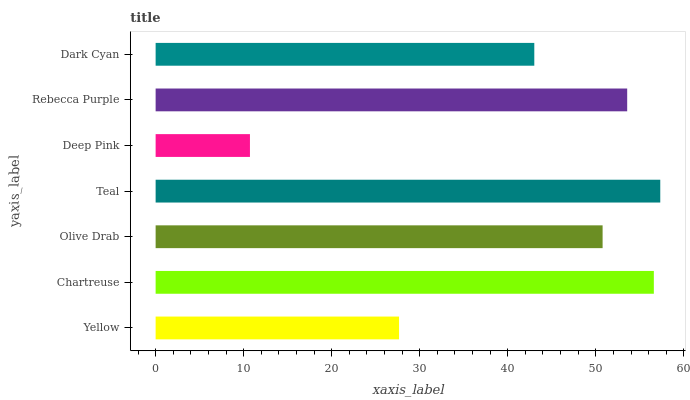Is Deep Pink the minimum?
Answer yes or no. Yes. Is Teal the maximum?
Answer yes or no. Yes. Is Chartreuse the minimum?
Answer yes or no. No. Is Chartreuse the maximum?
Answer yes or no. No. Is Chartreuse greater than Yellow?
Answer yes or no. Yes. Is Yellow less than Chartreuse?
Answer yes or no. Yes. Is Yellow greater than Chartreuse?
Answer yes or no. No. Is Chartreuse less than Yellow?
Answer yes or no. No. Is Olive Drab the high median?
Answer yes or no. Yes. Is Olive Drab the low median?
Answer yes or no. Yes. Is Teal the high median?
Answer yes or no. No. Is Deep Pink the low median?
Answer yes or no. No. 